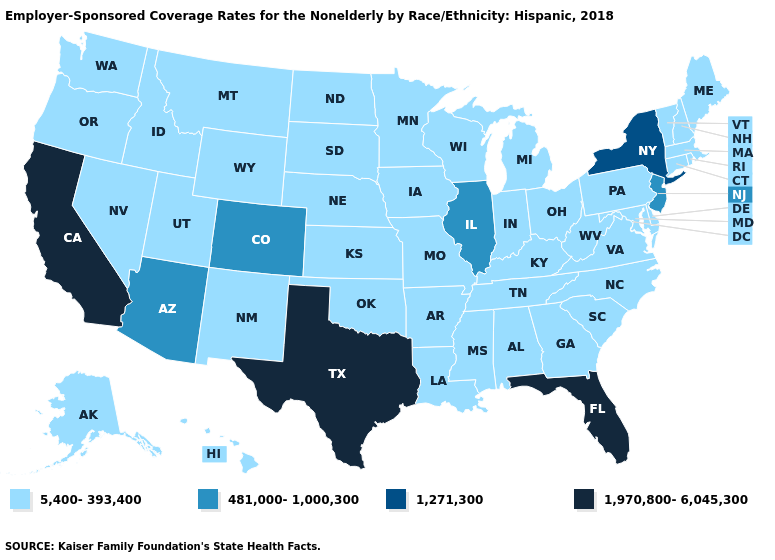Does Indiana have the lowest value in the USA?
Answer briefly. Yes. Which states have the highest value in the USA?
Quick response, please. California, Florida, Texas. What is the value of Nevada?
Concise answer only. 5,400-393,400. Name the states that have a value in the range 481,000-1,000,300?
Quick response, please. Arizona, Colorado, Illinois, New Jersey. What is the highest value in the Northeast ?
Write a very short answer. 1,271,300. Does Kentucky have the same value as Texas?
Be succinct. No. What is the value of Oregon?
Answer briefly. 5,400-393,400. Name the states that have a value in the range 1,970,800-6,045,300?
Concise answer only. California, Florida, Texas. Name the states that have a value in the range 1,970,800-6,045,300?
Concise answer only. California, Florida, Texas. Does California have the highest value in the USA?
Short answer required. Yes. Which states have the lowest value in the USA?
Write a very short answer. Alabama, Alaska, Arkansas, Connecticut, Delaware, Georgia, Hawaii, Idaho, Indiana, Iowa, Kansas, Kentucky, Louisiana, Maine, Maryland, Massachusetts, Michigan, Minnesota, Mississippi, Missouri, Montana, Nebraska, Nevada, New Hampshire, New Mexico, North Carolina, North Dakota, Ohio, Oklahoma, Oregon, Pennsylvania, Rhode Island, South Carolina, South Dakota, Tennessee, Utah, Vermont, Virginia, Washington, West Virginia, Wisconsin, Wyoming. How many symbols are there in the legend?
Concise answer only. 4. How many symbols are there in the legend?
Quick response, please. 4. Name the states that have a value in the range 1,970,800-6,045,300?
Keep it brief. California, Florida, Texas. 